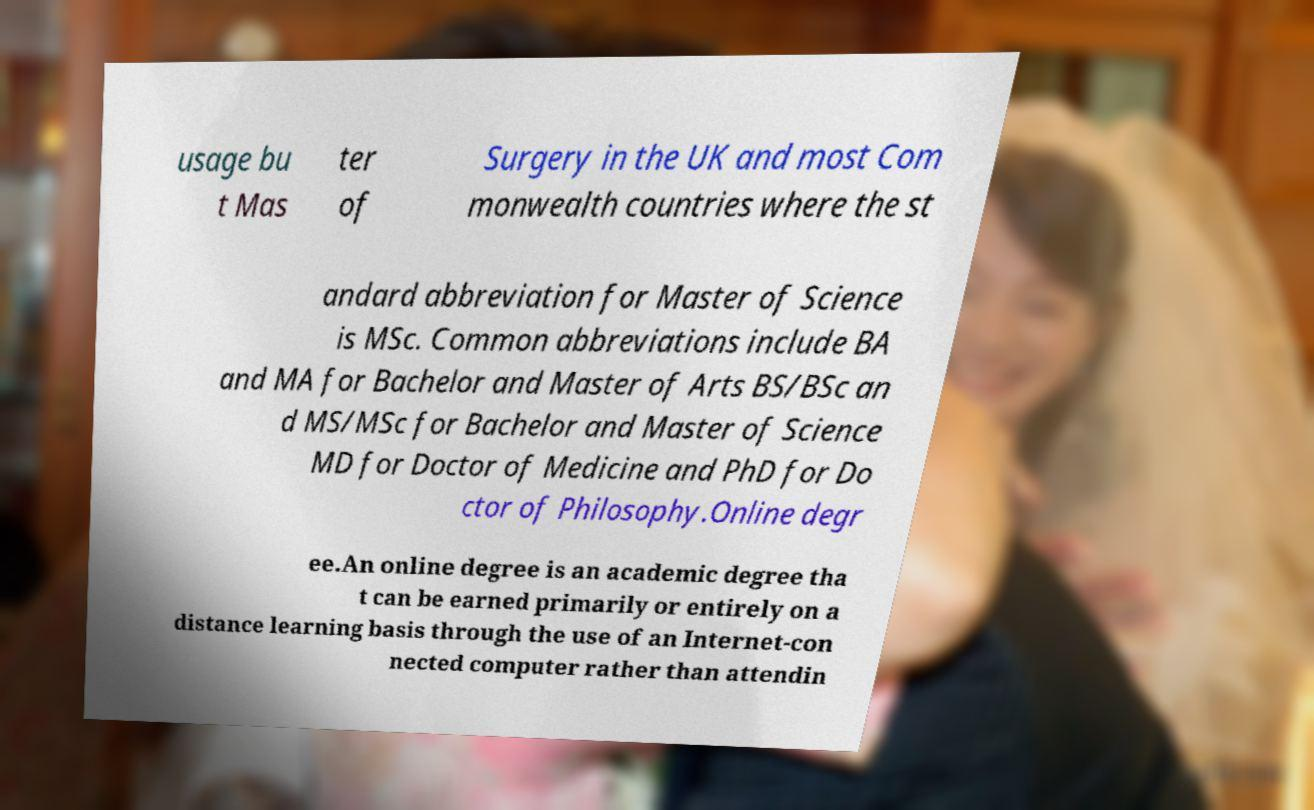Could you extract and type out the text from this image? usage bu t Mas ter of Surgery in the UK and most Com monwealth countries where the st andard abbreviation for Master of Science is MSc. Common abbreviations include BA and MA for Bachelor and Master of Arts BS/BSc an d MS/MSc for Bachelor and Master of Science MD for Doctor of Medicine and PhD for Do ctor of Philosophy.Online degr ee.An online degree is an academic degree tha t can be earned primarily or entirely on a distance learning basis through the use of an Internet-con nected computer rather than attendin 